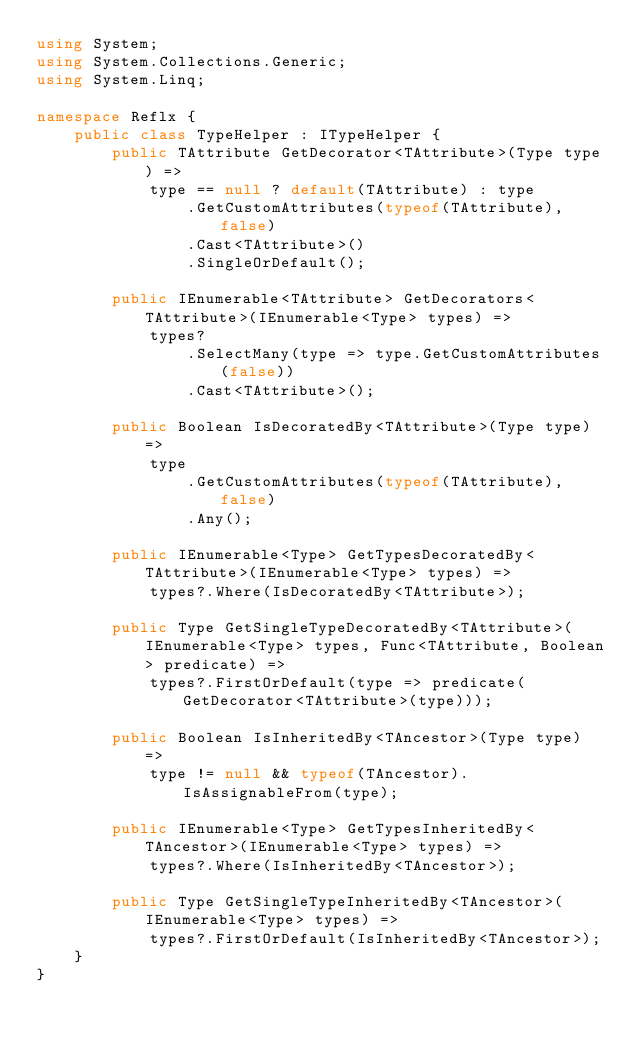Convert code to text. <code><loc_0><loc_0><loc_500><loc_500><_C#_>using System;
using System.Collections.Generic;
using System.Linq;

namespace Reflx {
    public class TypeHelper : ITypeHelper {
        public TAttribute GetDecorator<TAttribute>(Type type) =>
            type == null ? default(TAttribute) : type
                .GetCustomAttributes(typeof(TAttribute), false)
                .Cast<TAttribute>()
                .SingleOrDefault();

        public IEnumerable<TAttribute> GetDecorators<TAttribute>(IEnumerable<Type> types) =>
            types?
                .SelectMany(type => type.GetCustomAttributes(false))
                .Cast<TAttribute>();

        public Boolean IsDecoratedBy<TAttribute>(Type type) =>
            type
                .GetCustomAttributes(typeof(TAttribute), false)
                .Any();

        public IEnumerable<Type> GetTypesDecoratedBy<TAttribute>(IEnumerable<Type> types) =>
            types?.Where(IsDecoratedBy<TAttribute>);

        public Type GetSingleTypeDecoratedBy<TAttribute>(IEnumerable<Type> types, Func<TAttribute, Boolean> predicate) =>
            types?.FirstOrDefault(type => predicate(GetDecorator<TAttribute>(type)));

        public Boolean IsInheritedBy<TAncestor>(Type type) =>
            type != null && typeof(TAncestor).IsAssignableFrom(type);

        public IEnumerable<Type> GetTypesInheritedBy<TAncestor>(IEnumerable<Type> types) =>
            types?.Where(IsInheritedBy<TAncestor>);

        public Type GetSingleTypeInheritedBy<TAncestor>(IEnumerable<Type> types) =>
            types?.FirstOrDefault(IsInheritedBy<TAncestor>);
    }
}
</code> 